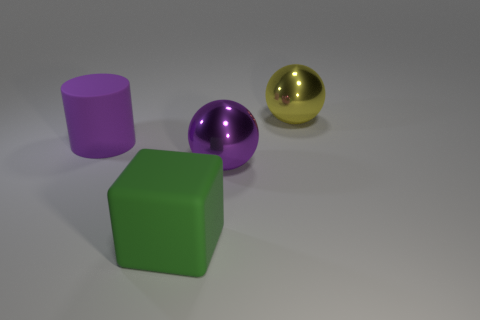Is the green rubber thing the same shape as the purple shiny object?
Ensure brevity in your answer.  No. There is a large rubber object in front of the large purple matte cylinder; is its color the same as the big thing left of the large green thing?
Your answer should be very brief. No. What is the color of the cylinder that is the same size as the green thing?
Keep it short and to the point. Purple. How many other objects are there of the same shape as the purple metallic object?
Your answer should be compact. 1. What size is the purple object that is on the right side of the large block?
Your answer should be compact. Large. How many rubber objects are behind the big matte thing that is in front of the large purple rubber object?
Your answer should be very brief. 1. What number of other things are the same size as the green object?
Provide a short and direct response. 3. Do the rubber cylinder and the large matte block have the same color?
Provide a succinct answer. No. Do the metallic thing on the left side of the large yellow ball and the large yellow metallic thing have the same shape?
Provide a succinct answer. Yes. How many big things are behind the big purple shiny thing and right of the large rubber cube?
Give a very brief answer. 1. 